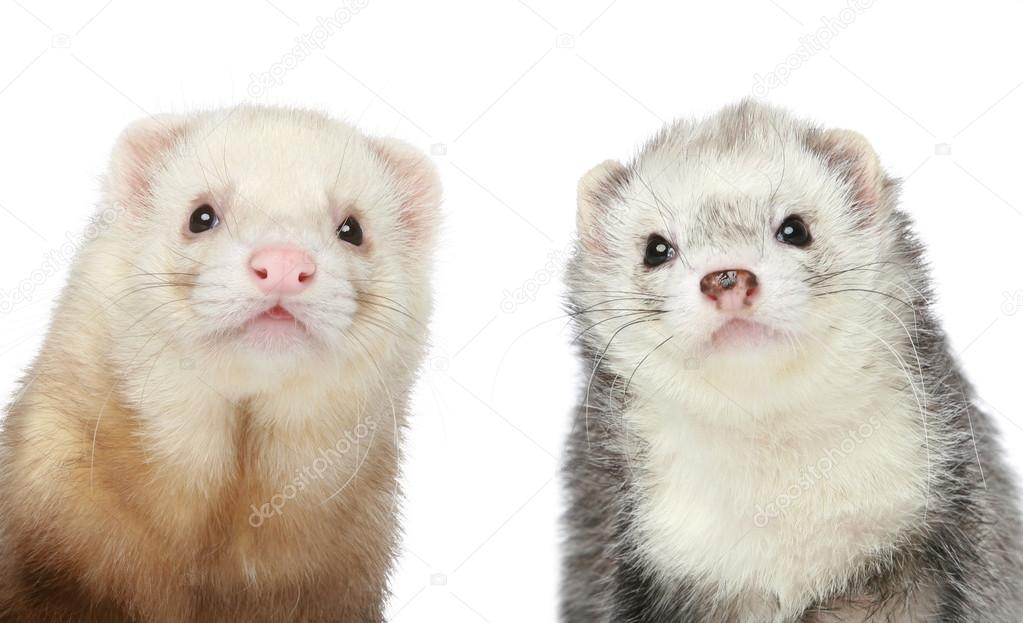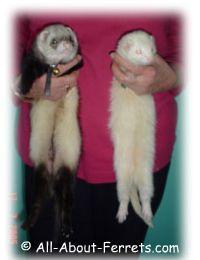The first image is the image on the left, the second image is the image on the right. Evaluate the accuracy of this statement regarding the images: "Two ferrets are standing.". Is it true? Answer yes or no. No. The first image is the image on the left, the second image is the image on the right. Given the left and right images, does the statement "The left image shows side-by-side ferrets standing on their own feet, and the right image shows a single forward-facing ferret." hold true? Answer yes or no. No. 